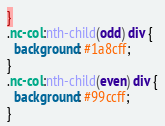<code> <loc_0><loc_0><loc_500><loc_500><_CSS_>}
.nc-col:nth-child(odd) div {
  background: #1a8cff;
}
.nc-col:nth-child(even) div {
  background: #99ccff;
}
</code> 